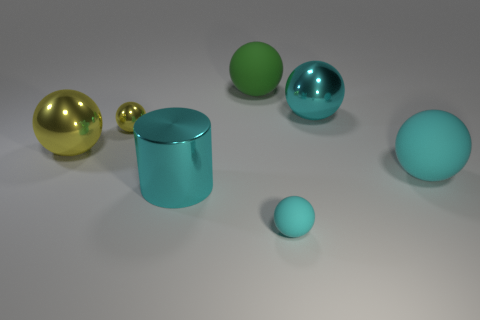How many cyan balls must be subtracted to get 1 cyan balls? 2 Subtract all tiny yellow shiny spheres. How many spheres are left? 5 Add 2 large cyan spheres. How many objects exist? 9 Subtract 1 cylinders. How many cylinders are left? 0 Subtract all green spheres. How many spheres are left? 5 Subtract 0 green cylinders. How many objects are left? 7 Subtract all cylinders. How many objects are left? 6 Subtract all brown spheres. Subtract all gray cylinders. How many spheres are left? 6 Subtract all brown cubes. How many cyan spheres are left? 3 Subtract all large spheres. Subtract all green rubber balls. How many objects are left? 2 